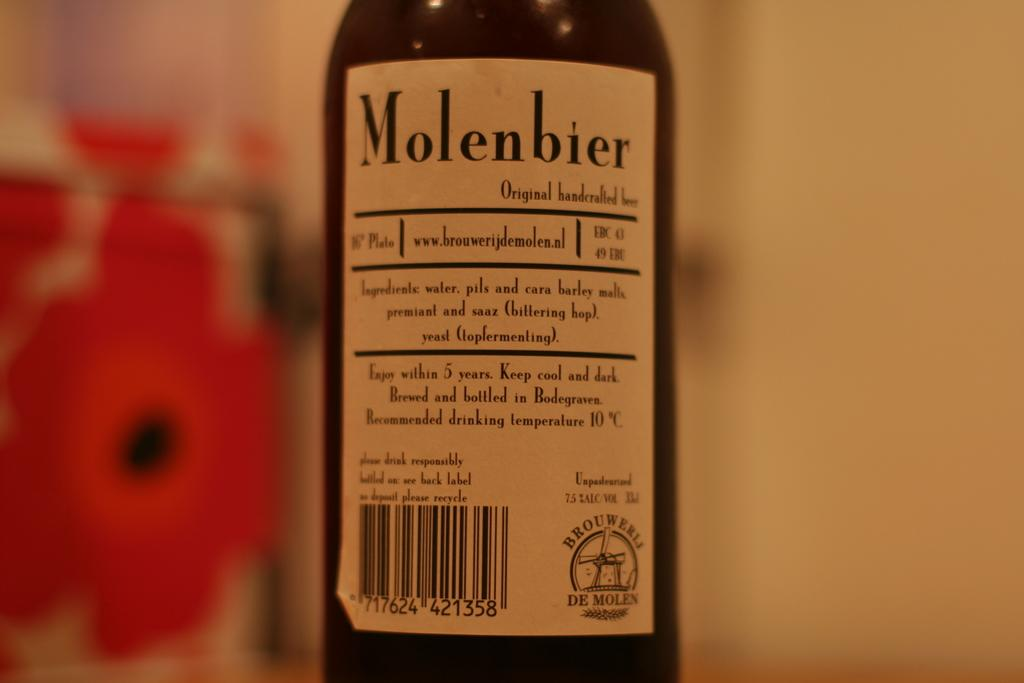What is the color of the bottle in the image? The bottle in the image is black. What is written on the label of the bottle? The label on the bottle has the text "molenbier" on it. What type of bottle is it? The bottle is described as an alcohol bottle. Can you see any spades or waves in the image? No, there are no spades or waves present in the image. 